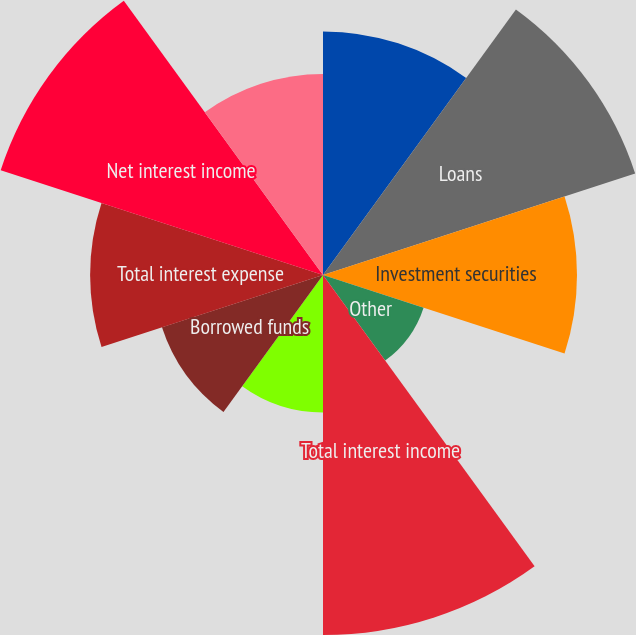<chart> <loc_0><loc_0><loc_500><loc_500><pie_chart><fcel>In millions except per share<fcel>Loans<fcel>Investment securities<fcel>Other<fcel>Total interest income<fcel>Deposits<fcel>Borrowed funds<fcel>Total interest expense<fcel>Net interest income<fcel>Asset management<nl><fcel>10.27%<fcel>13.84%<fcel>10.71%<fcel>4.46%<fcel>15.18%<fcel>5.8%<fcel>7.14%<fcel>9.82%<fcel>14.29%<fcel>8.48%<nl></chart> 